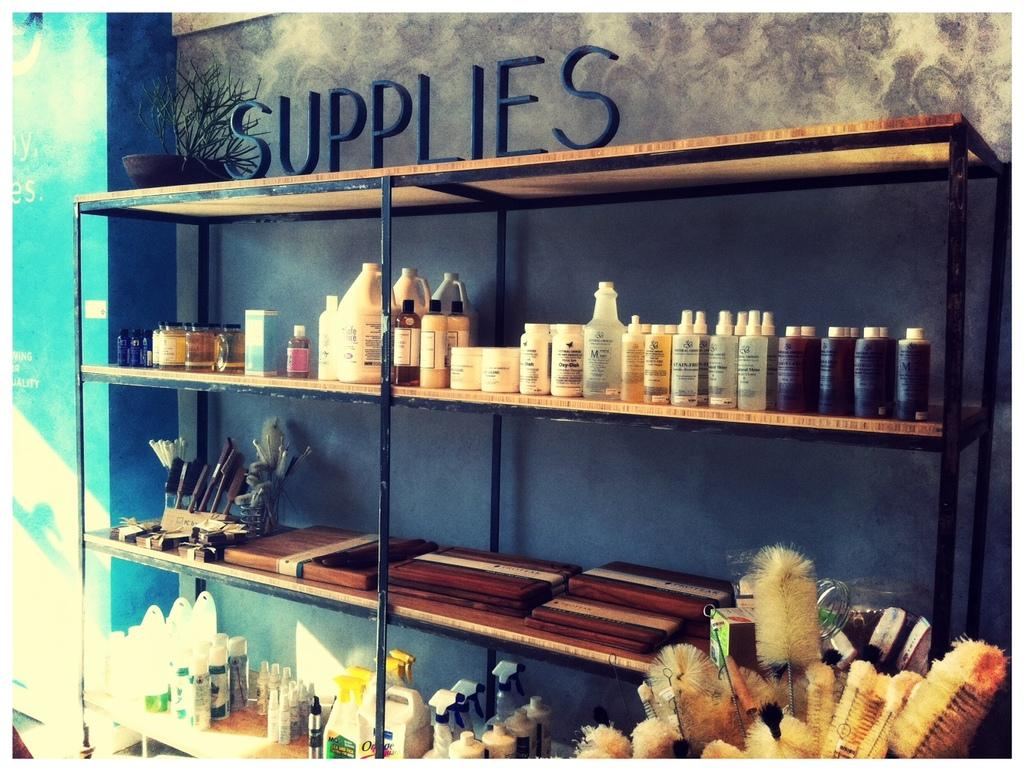<image>
Relay a brief, clear account of the picture shown. Shelf of items and also the word "Supplies" on top. 